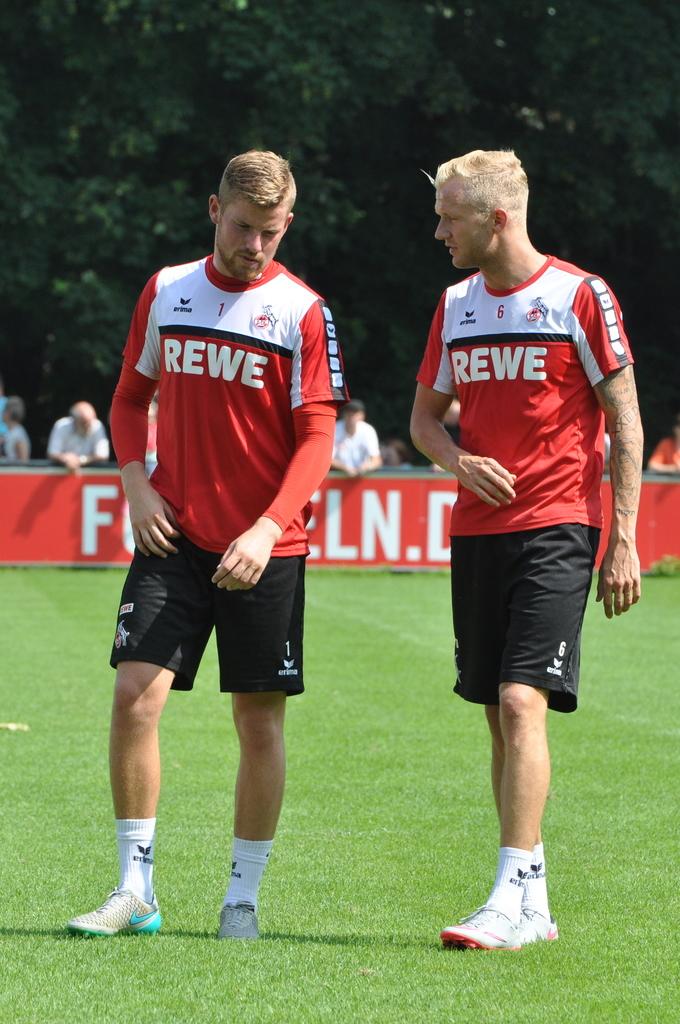Who is playing the game?
Give a very brief answer. Rewe. What number is the player on the right?
Your answer should be very brief. 6. 